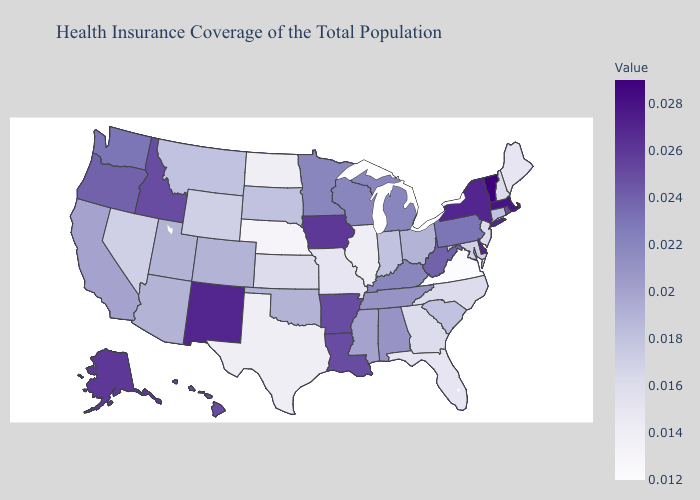Does Louisiana have the lowest value in the South?
Give a very brief answer. No. Does Nevada have a lower value than Illinois?
Write a very short answer. No. Among the states that border Idaho , which have the highest value?
Keep it brief. Oregon. Which states have the lowest value in the MidWest?
Concise answer only. Nebraska. Is the legend a continuous bar?
Give a very brief answer. Yes. Does Georgia have the lowest value in the South?
Concise answer only. No. 